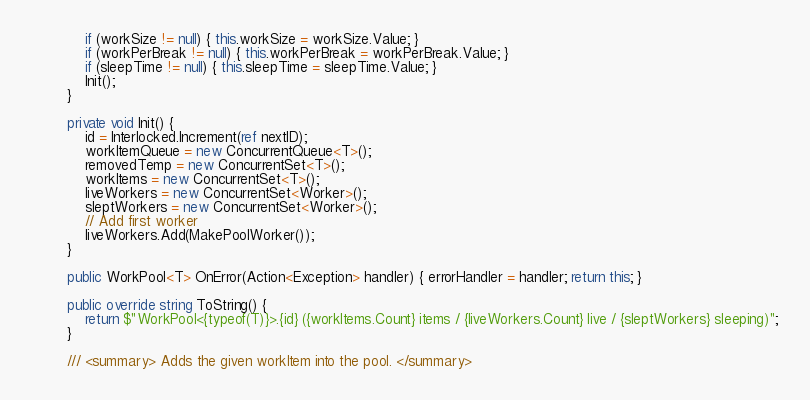Convert code to text. <code><loc_0><loc_0><loc_500><loc_500><_C#_>			if (workSize != null) { this.workSize = workSize.Value; }
			if (workPerBreak != null) { this.workPerBreak = workPerBreak.Value; }
			if (sleepTime != null) { this.sleepTime = sleepTime.Value; }
			Init();
		}

		private void Init() {
			id = Interlocked.Increment(ref nextID);
			workItemQueue = new ConcurrentQueue<T>();
			removedTemp = new ConcurrentSet<T>();
			workItems = new ConcurrentSet<T>();
			liveWorkers = new ConcurrentSet<Worker>();
			sleptWorkers = new ConcurrentSet<Worker>();
			// Add first worker
			liveWorkers.Add(MakePoolWorker());
		}

		public WorkPool<T> OnError(Action<Exception> handler) { errorHandler = handler; return this; }

		public override string ToString() {
			return $"WorkPool<{typeof(T)}>.{id} ({workItems.Count} items / {liveWorkers.Count} live / {sleptWorkers} sleeping)";
		}

		/// <summary> Adds the given workItem into the pool. </summary></code> 